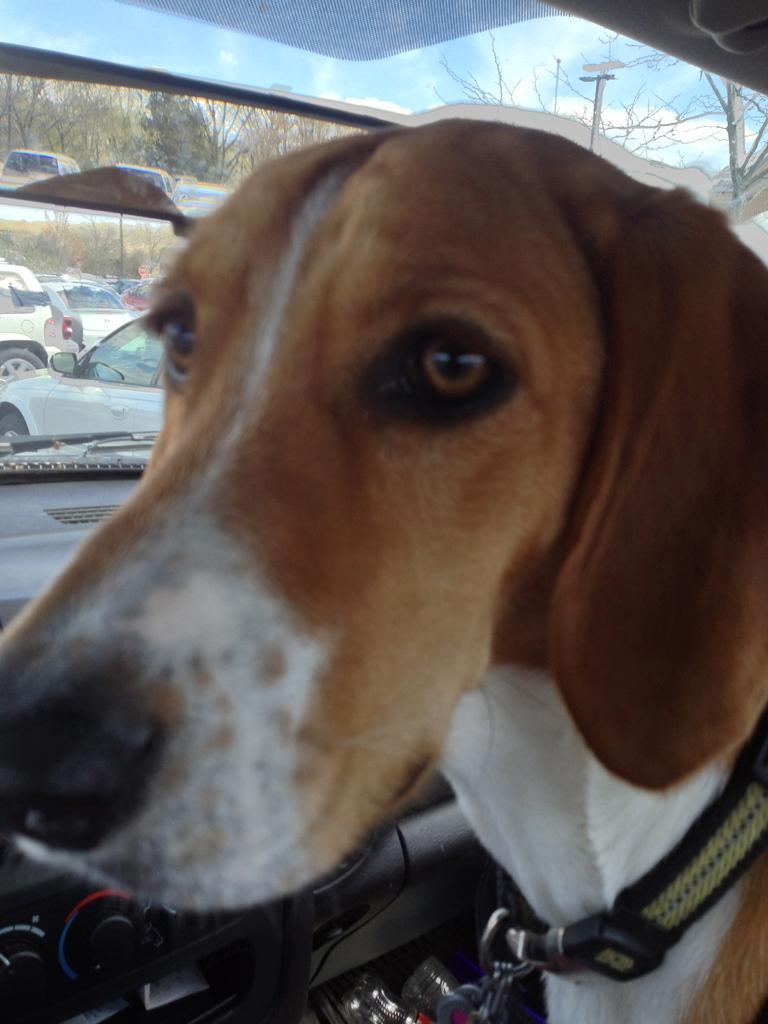How would you summarize this image in a sentence or two? This picture is mainly highlighted with a dog inside a car. Through window glass we can see few cars and trees and also a clear blue sky with clouds. 